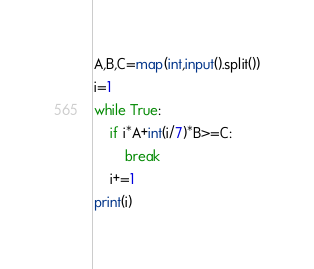<code> <loc_0><loc_0><loc_500><loc_500><_Python_>A,B,C=map(int,input().split())
i=1
while True:
    if i*A+int(i/7)*B>=C:
        break
    i+=1
print(i)    
</code> 